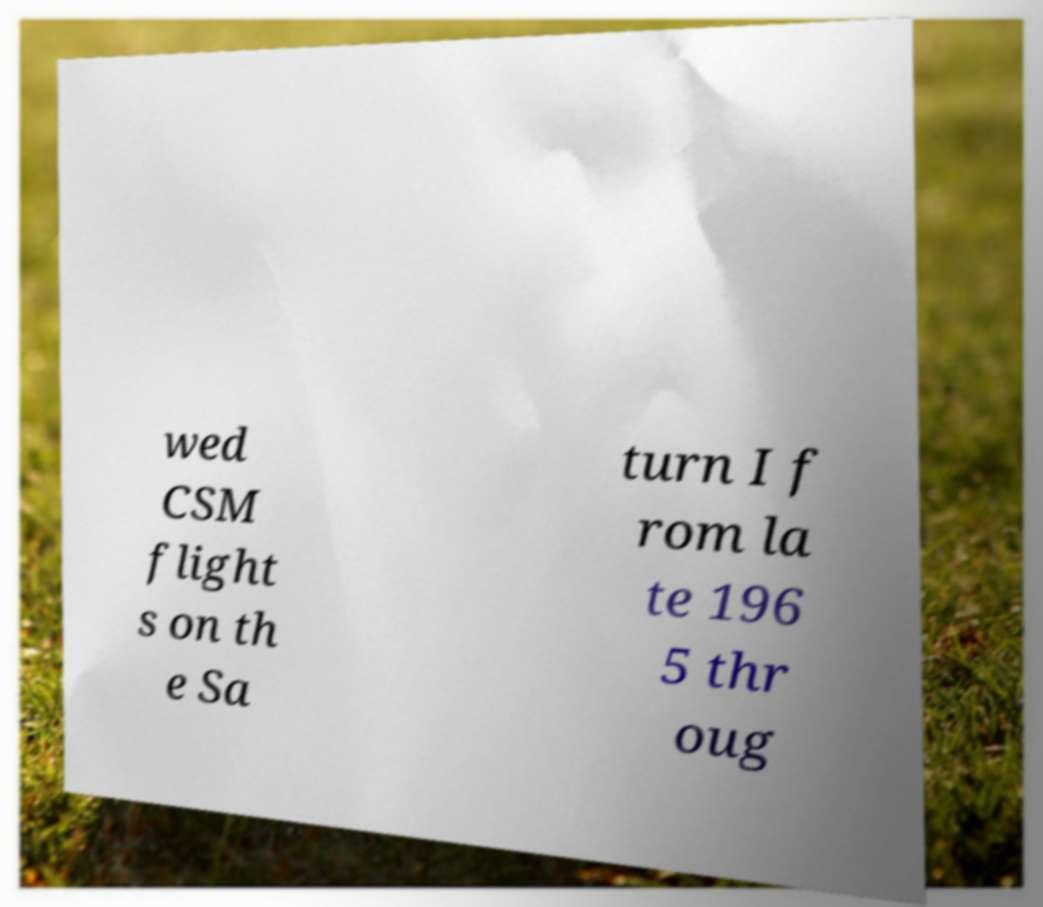Could you extract and type out the text from this image? wed CSM flight s on th e Sa turn I f rom la te 196 5 thr oug 